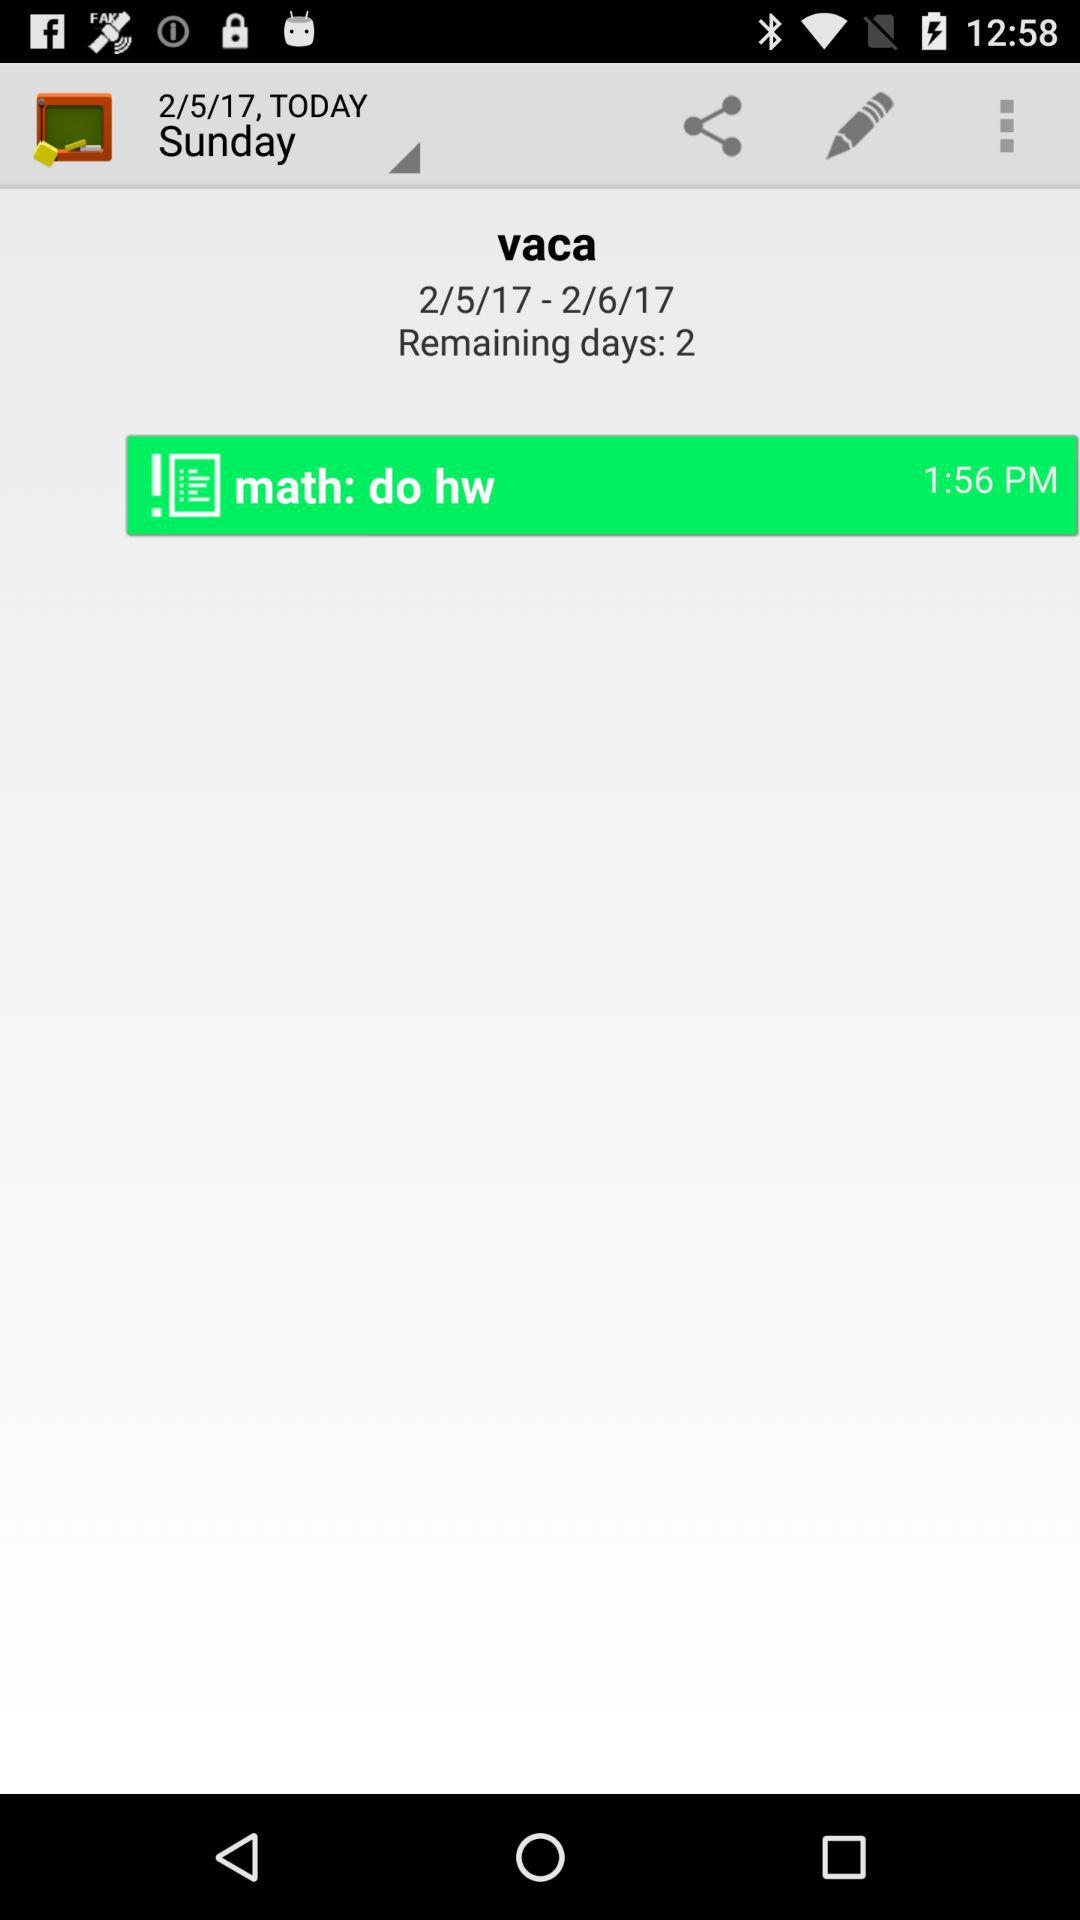How many days are left in the vacation?
Answer the question using a single word or phrase. 2 